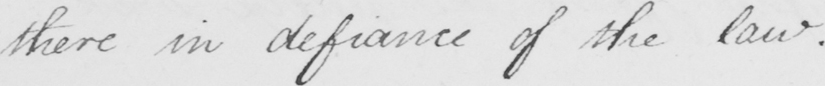What text is written in this handwritten line? there in defiance of the law . 